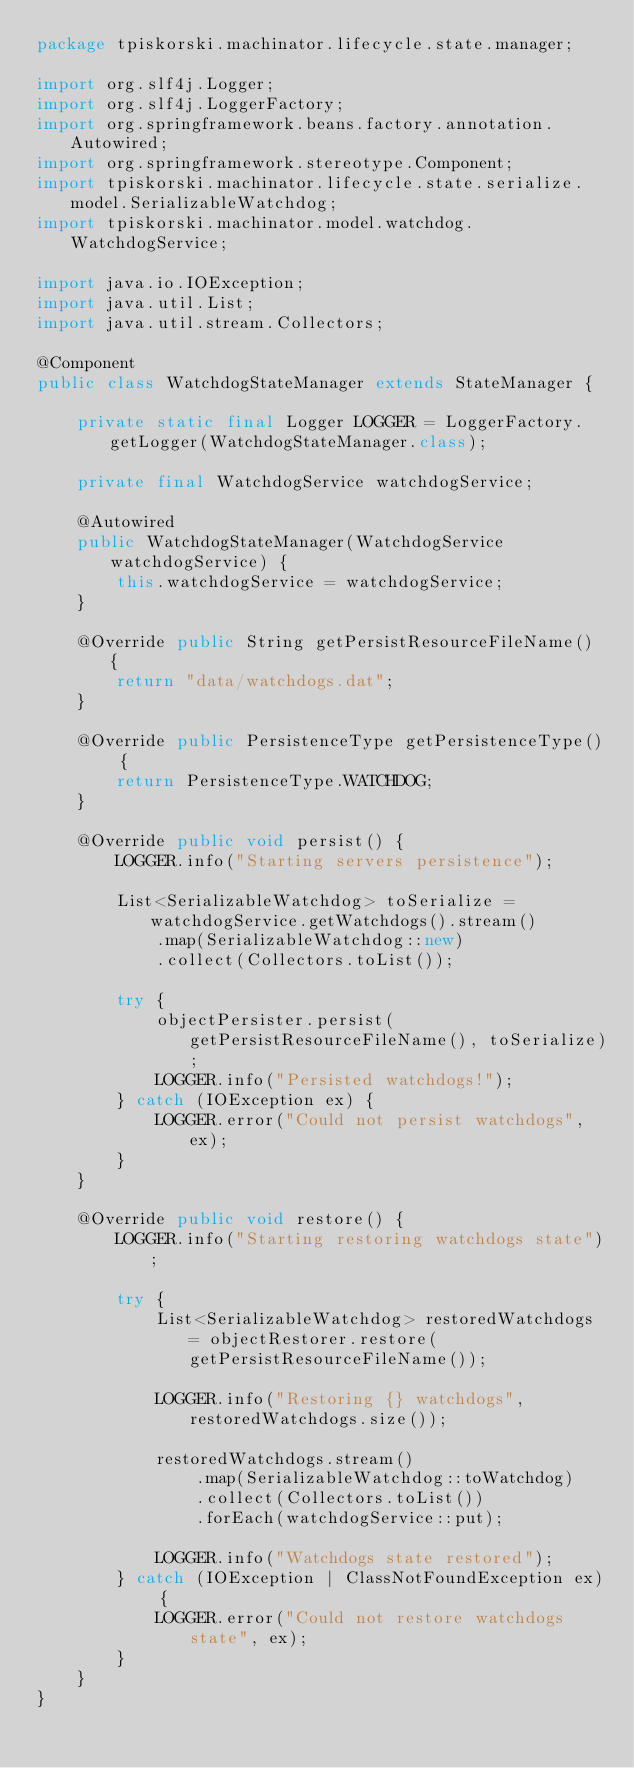Convert code to text. <code><loc_0><loc_0><loc_500><loc_500><_Java_>package tpiskorski.machinator.lifecycle.state.manager;

import org.slf4j.Logger;
import org.slf4j.LoggerFactory;
import org.springframework.beans.factory.annotation.Autowired;
import org.springframework.stereotype.Component;
import tpiskorski.machinator.lifecycle.state.serialize.model.SerializableWatchdog;
import tpiskorski.machinator.model.watchdog.WatchdogService;

import java.io.IOException;
import java.util.List;
import java.util.stream.Collectors;

@Component
public class WatchdogStateManager extends StateManager {

    private static final Logger LOGGER = LoggerFactory.getLogger(WatchdogStateManager.class);

    private final WatchdogService watchdogService;

    @Autowired
    public WatchdogStateManager(WatchdogService watchdogService) {
        this.watchdogService = watchdogService;
    }

    @Override public String getPersistResourceFileName() {
        return "data/watchdogs.dat";
    }

    @Override public PersistenceType getPersistenceType() {
        return PersistenceType.WATCHDOG;
    }

    @Override public void persist() {
        LOGGER.info("Starting servers persistence");

        List<SerializableWatchdog> toSerialize = watchdogService.getWatchdogs().stream()
            .map(SerializableWatchdog::new)
            .collect(Collectors.toList());

        try {
            objectPersister.persist(getPersistResourceFileName(), toSerialize);
            LOGGER.info("Persisted watchdogs!");
        } catch (IOException ex) {
            LOGGER.error("Could not persist watchdogs", ex);
        }
    }

    @Override public void restore() {
        LOGGER.info("Starting restoring watchdogs state");

        try {
            List<SerializableWatchdog> restoredWatchdogs = objectRestorer.restore(getPersistResourceFileName());

            LOGGER.info("Restoring {} watchdogs", restoredWatchdogs.size());

            restoredWatchdogs.stream()
                .map(SerializableWatchdog::toWatchdog)
                .collect(Collectors.toList())
                .forEach(watchdogService::put);

            LOGGER.info("Watchdogs state restored");
        } catch (IOException | ClassNotFoundException ex) {
            LOGGER.error("Could not restore watchdogs state", ex);
        }
    }
}
</code> 